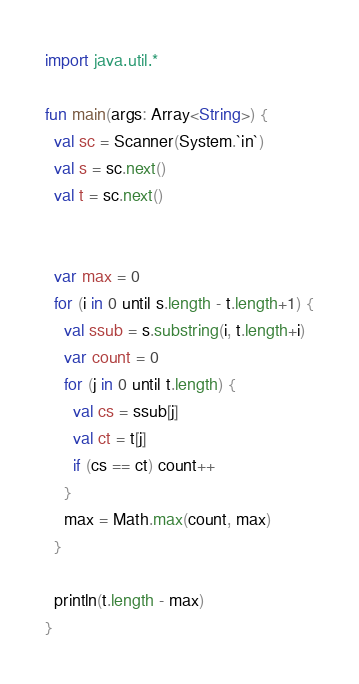Convert code to text. <code><loc_0><loc_0><loc_500><loc_500><_Kotlin_>import java.util.*

fun main(args: Array<String>) {
  val sc = Scanner(System.`in`)
  val s = sc.next()
  val t = sc.next()


  var max = 0
  for (i in 0 until s.length - t.length+1) {
    val ssub = s.substring(i, t.length+i)
    var count = 0
    for (j in 0 until t.length) {
      val cs = ssub[j]
      val ct = t[j]
      if (cs == ct) count++
    }
    max = Math.max(count, max)
  }

  println(t.length - max)
}
</code> 